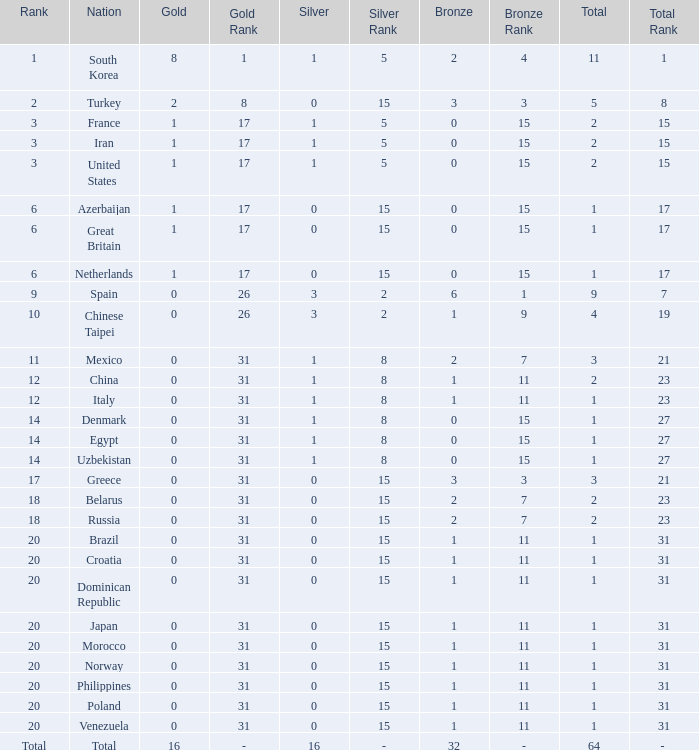How many total silvers does Russia have? 1.0. 